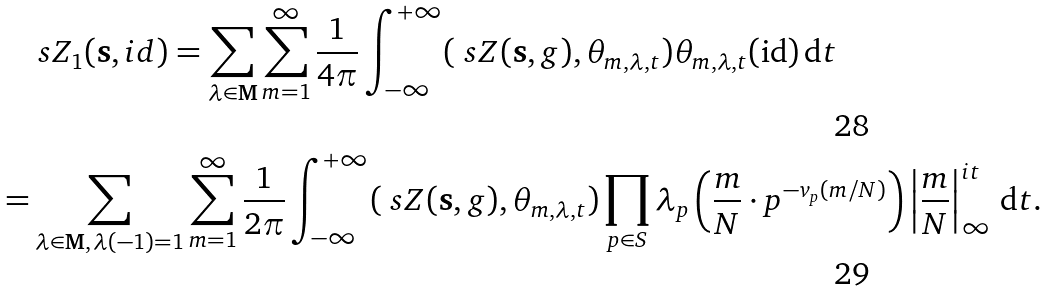<formula> <loc_0><loc_0><loc_500><loc_500>& \ s Z _ { 1 } ( \mathbf s , i d ) = \sum _ { \lambda \in \mathbf M } \sum _ { m = 1 } ^ { \infty } \frac { 1 } { 4 \pi } \int _ { - \infty } ^ { + \infty } ( \ s Z ( \mathbf s , g ) , \theta _ { m , \lambda , t } ) \theta _ { m , \lambda , t } ( \text {id} ) \, \mathrm d t \\ = & \sum _ { \lambda \in \mathbf M , \, \lambda ( - 1 ) = 1 } \sum _ { m = 1 } ^ { \infty } \frac { 1 } { 2 \pi } \int _ { - \infty } ^ { + \infty } ( \ s Z ( \mathbf s , g ) , \theta _ { m , \lambda , t } ) \prod _ { p \in S } \lambda _ { p } \left ( \frac { m } { N } \cdot p ^ { - v _ { p } ( m / N ) } \right ) \left | \frac { m } { N } \right | _ { \infty } ^ { i t } \, \mathrm d t .</formula> 